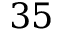Convert formula to latex. <formula><loc_0><loc_0><loc_500><loc_500>3 5</formula> 